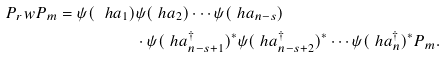<formula> <loc_0><loc_0><loc_500><loc_500>P _ { r } w P _ { m } = \psi ( \ h a _ { 1 } ) & \psi ( \ h a _ { 2 } ) \cdots \psi ( \ h a _ { n - s } ) \\ & \cdot \psi ( \ h a _ { n - s + 1 } ^ { \dag } ) ^ { * } \psi ( \ h a _ { n - s + 2 } ^ { \dag } ) ^ { * } \cdots \psi ( \ h a _ { n } ^ { \dag } ) ^ { * } P _ { m } .</formula> 